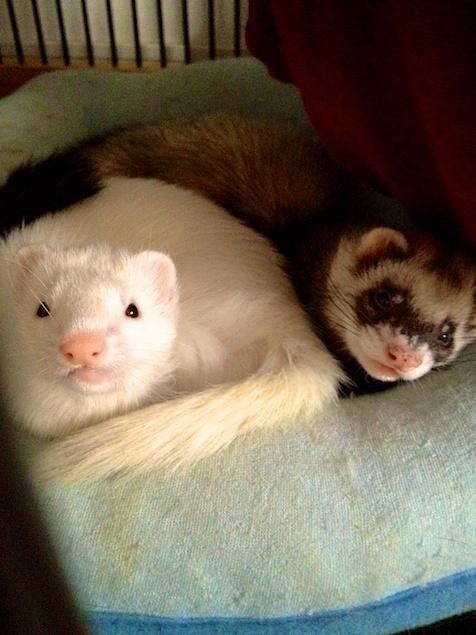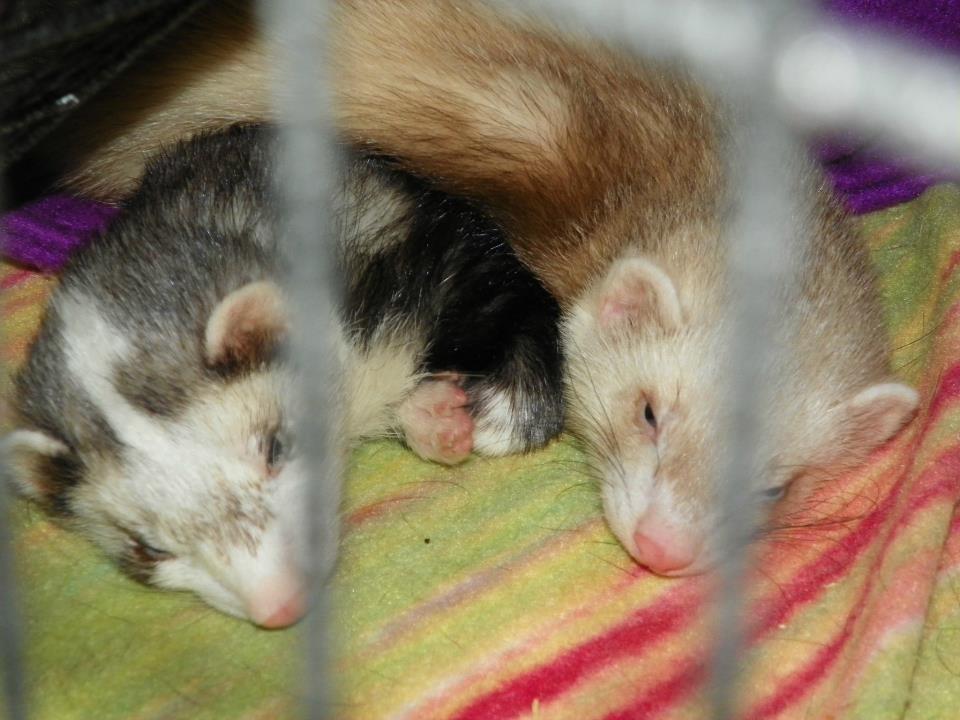The first image is the image on the left, the second image is the image on the right. Examine the images to the left and right. Is the description "In one image there is a lone ferret sleeping with its tongue sticking out." accurate? Answer yes or no. No. The first image is the image on the left, the second image is the image on the right. Evaluate the accuracy of this statement regarding the images: "There are exactly three ferrets in total.". Is it true? Answer yes or no. No. 